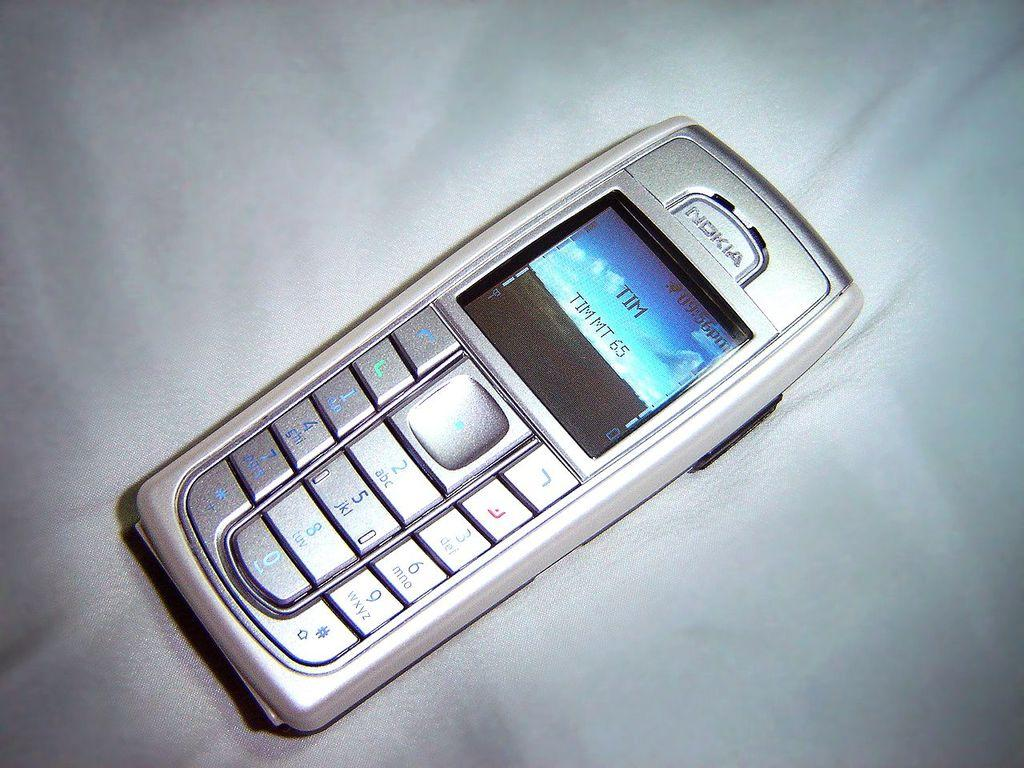What electronic device is visible in the image? There is a mobile phone in the image. Where is the mobile phone located? The mobile phone is on a surface. How many dolls are playing in the yard in the image? There are no dolls or yards present in the image; it only features a mobile phone on a surface. 